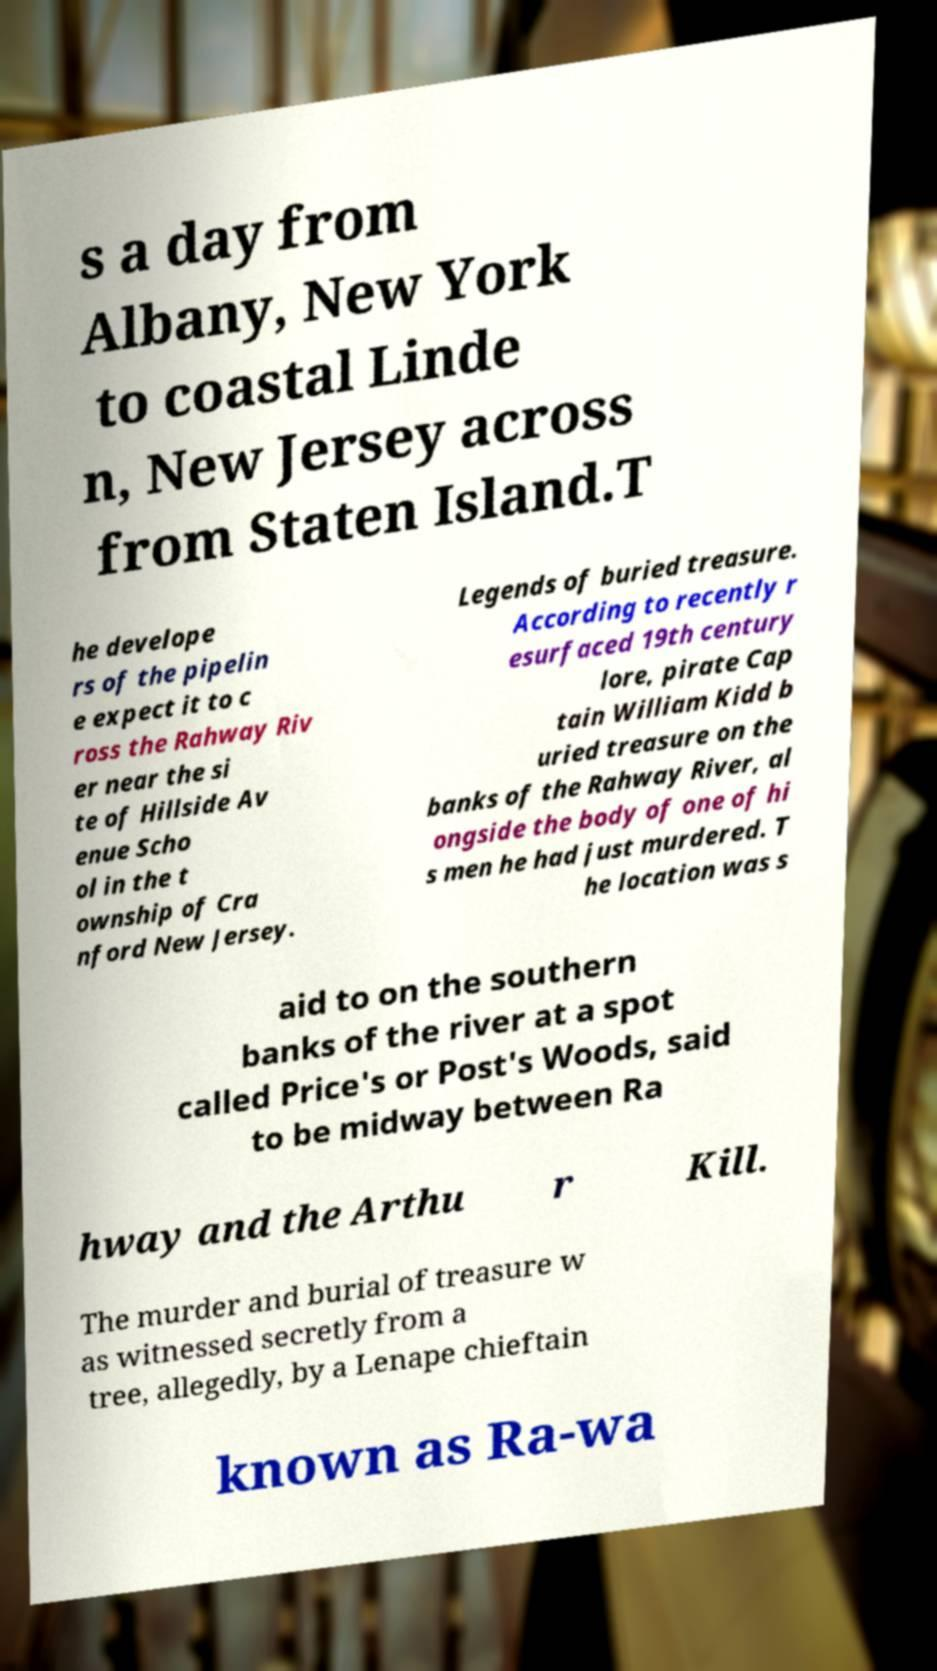Can you read and provide the text displayed in the image?This photo seems to have some interesting text. Can you extract and type it out for me? s a day from Albany, New York to coastal Linde n, New Jersey across from Staten Island.T he develope rs of the pipelin e expect it to c ross the Rahway Riv er near the si te of Hillside Av enue Scho ol in the t ownship of Cra nford New Jersey. Legends of buried treasure. According to recently r esurfaced 19th century lore, pirate Cap tain William Kidd b uried treasure on the banks of the Rahway River, al ongside the body of one of hi s men he had just murdered. T he location was s aid to on the southern banks of the river at a spot called Price's or Post's Woods, said to be midway between Ra hway and the Arthu r Kill. The murder and burial of treasure w as witnessed secretly from a tree, allegedly, by a Lenape chieftain known as Ra-wa 